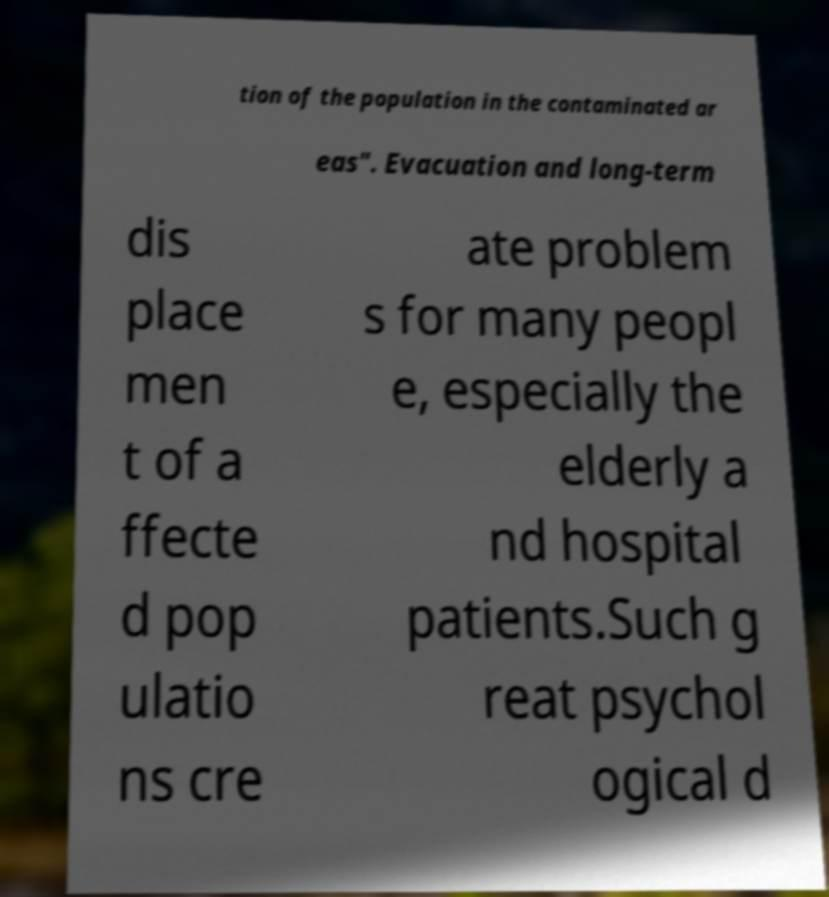Can you accurately transcribe the text from the provided image for me? tion of the population in the contaminated ar eas". Evacuation and long-term dis place men t of a ffecte d pop ulatio ns cre ate problem s for many peopl e, especially the elderly a nd hospital patients.Such g reat psychol ogical d 